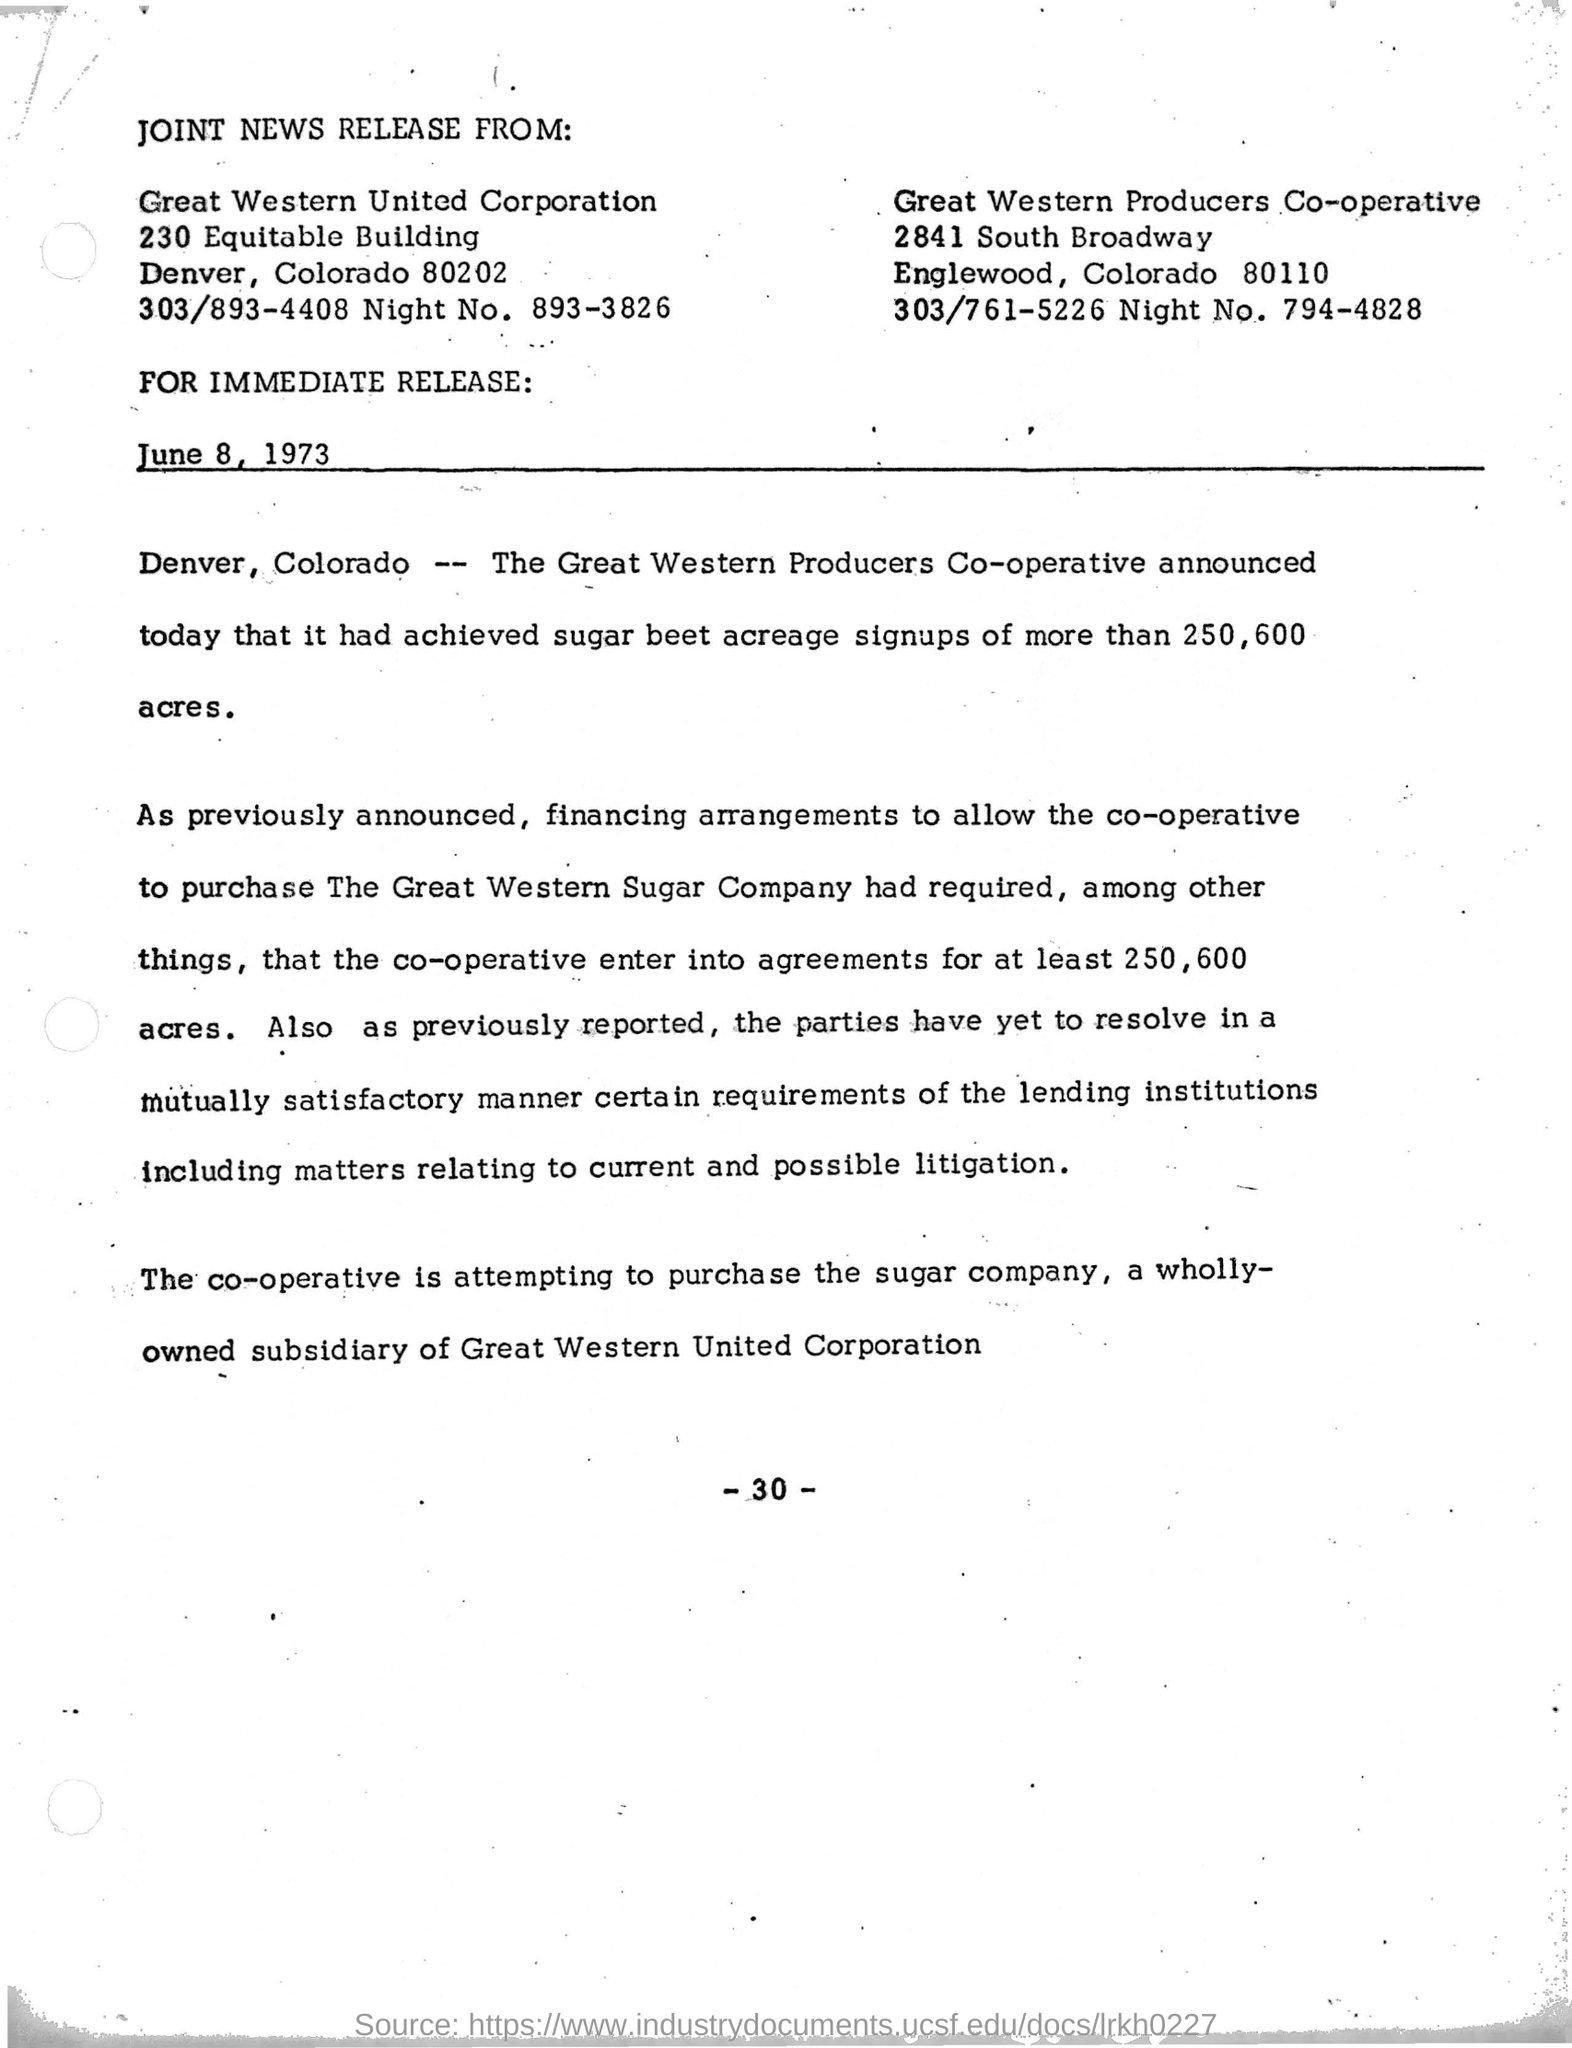Highlight a few significant elements in this photo. The date mentioned in the text is June 8, 1973. 